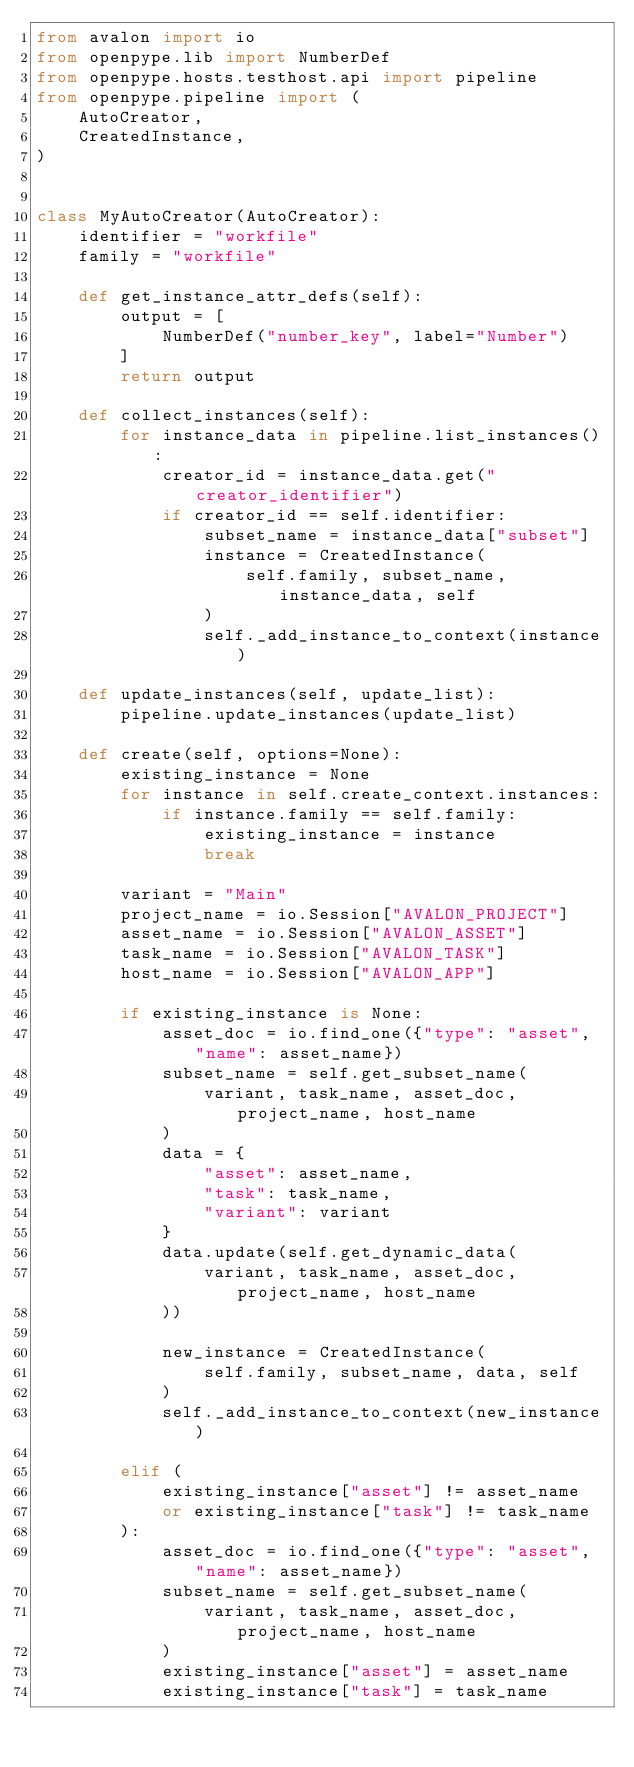Convert code to text. <code><loc_0><loc_0><loc_500><loc_500><_Python_>from avalon import io
from openpype.lib import NumberDef
from openpype.hosts.testhost.api import pipeline
from openpype.pipeline import (
    AutoCreator,
    CreatedInstance,
)


class MyAutoCreator(AutoCreator):
    identifier = "workfile"
    family = "workfile"

    def get_instance_attr_defs(self):
        output = [
            NumberDef("number_key", label="Number")
        ]
        return output

    def collect_instances(self):
        for instance_data in pipeline.list_instances():
            creator_id = instance_data.get("creator_identifier")
            if creator_id == self.identifier:
                subset_name = instance_data["subset"]
                instance = CreatedInstance(
                    self.family, subset_name, instance_data, self
                )
                self._add_instance_to_context(instance)

    def update_instances(self, update_list):
        pipeline.update_instances(update_list)

    def create(self, options=None):
        existing_instance = None
        for instance in self.create_context.instances:
            if instance.family == self.family:
                existing_instance = instance
                break

        variant = "Main"
        project_name = io.Session["AVALON_PROJECT"]
        asset_name = io.Session["AVALON_ASSET"]
        task_name = io.Session["AVALON_TASK"]
        host_name = io.Session["AVALON_APP"]

        if existing_instance is None:
            asset_doc = io.find_one({"type": "asset", "name": asset_name})
            subset_name = self.get_subset_name(
                variant, task_name, asset_doc, project_name, host_name
            )
            data = {
                "asset": asset_name,
                "task": task_name,
                "variant": variant
            }
            data.update(self.get_dynamic_data(
                variant, task_name, asset_doc, project_name, host_name
            ))

            new_instance = CreatedInstance(
                self.family, subset_name, data, self
            )
            self._add_instance_to_context(new_instance)

        elif (
            existing_instance["asset"] != asset_name
            or existing_instance["task"] != task_name
        ):
            asset_doc = io.find_one({"type": "asset", "name": asset_name})
            subset_name = self.get_subset_name(
                variant, task_name, asset_doc, project_name, host_name
            )
            existing_instance["asset"] = asset_name
            existing_instance["task"] = task_name
</code> 